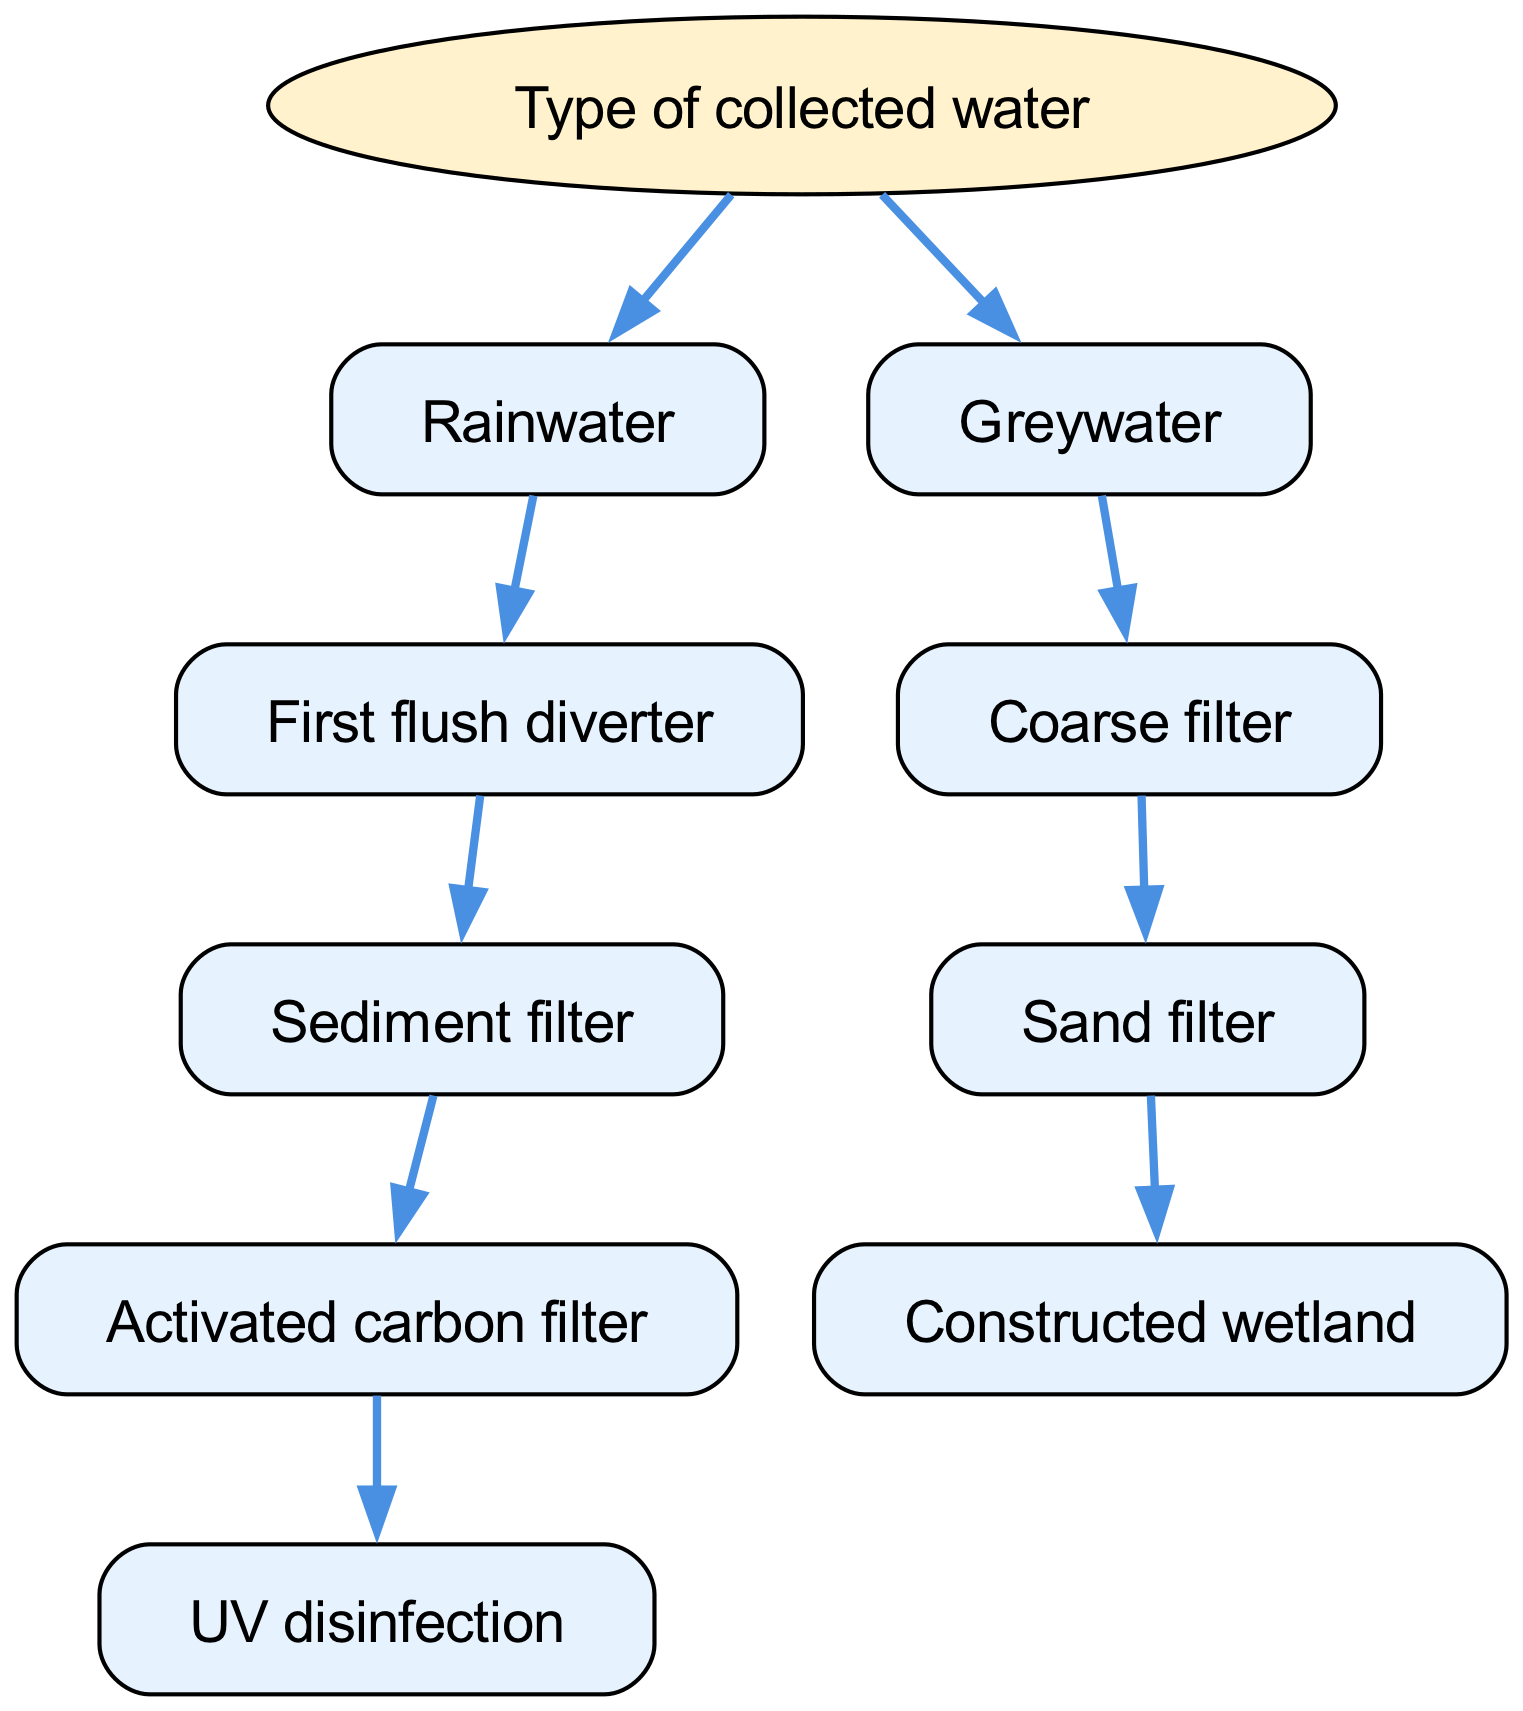What is the root node of the decision tree? The root node of the decision tree is "Type of collected water." This can be identified as the starting point of the tree diagram, which branches out into different types of collected water.
Answer: Type of collected water How many nodes are present in the rainwater filtration path? The rainwater filtration path includes five nodes: "Rainwater," "First flush diverter," "Sediment filter," "Activated carbon filter," and "UV disinfection." Each step in this path represents a stage of filtration for rainwater.
Answer: Five What is the last filtering stage for greywater? The last filtering stage for greywater is "Constructed wetland." This is the endpoint in the greywater filtration path that is documented in the diagram.
Answer: Constructed wetland Which filtration method comes after the "Coarse filter" in greywater treatment? After the "Coarse filter," the next method in greywater treatment is the "Sand filter." This follows directly in the decision tree hierarchy, indicating a sequence in the greywater filtration process.
Answer: Sand filter What types of water are covered in this decision tree? The decision tree covers two types of water: "Rainwater" and "Greywater." These are the categories that branch off from the root node, indicating the scope of filtration methods available.
Answer: Rainwater, Greywater If the collected water is rainwater, what is the second filtration step? If the collected water is categorized as rainwater, the second filtration step after "First flush diverter" is "Sediment filter." This follows logically from the filtration process sequence in the diagram.
Answer: Sediment filter How is UV disinfection related to rainwater filtration? UV disinfection is the final step in the rainwater filtration process. It follows the "Activated carbon filter," indicating it is the last stage to ensure the water is safe for usage.
Answer: Final step Which filtration method is specifically used for greywater treatment? The specific filtration method used for greywater treatment is "Coarse filter." This is the initial stage in the greywater filtration path highlighted in the decision tree.
Answer: Coarse filter What filtration method is not used in rainwater treatment? The "Constructed wetland" filtration method is not used in rainwater treatment, as it is specific to the greywater filtration path. The diagram clearly segregates the filtration methods for the different types of water.
Answer: Constructed wetland 